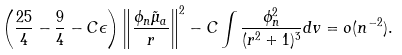Convert formula to latex. <formula><loc_0><loc_0><loc_500><loc_500>\left ( \frac { 2 5 } { 4 } - \frac { 9 } { 4 } - C \epsilon \right ) \left \| \frac { \phi _ { n } \tilde { \mu } _ { a } } { r } \right \| ^ { 2 } - C \int \frac { \phi _ { n } ^ { 2 } } { ( r ^ { 2 } + 1 ) ^ { 3 } } d v = o ( n ^ { - 2 } ) .</formula> 